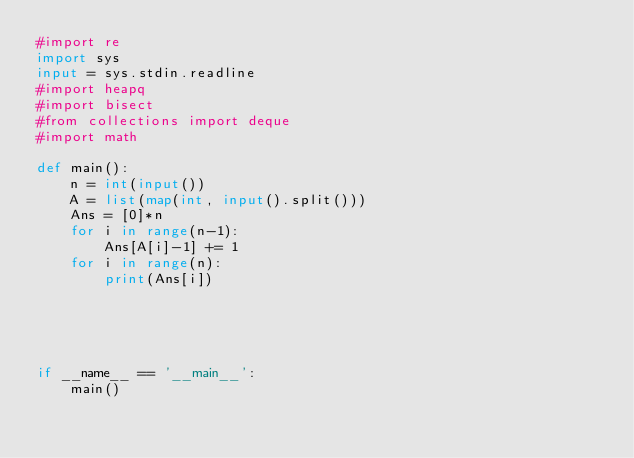Convert code to text. <code><loc_0><loc_0><loc_500><loc_500><_Python_>#import re
import sys
input = sys.stdin.readline
#import heapq
#import bisect
#from collections import deque
#import math

def main():
    n = int(input())
    A = list(map(int, input().split()))
    Ans = [0]*n
    for i in range(n-1):
        Ans[A[i]-1] += 1
    for i in range(n):
        print(Ans[i])

    


    
if __name__ == '__main__':
    main()
</code> 